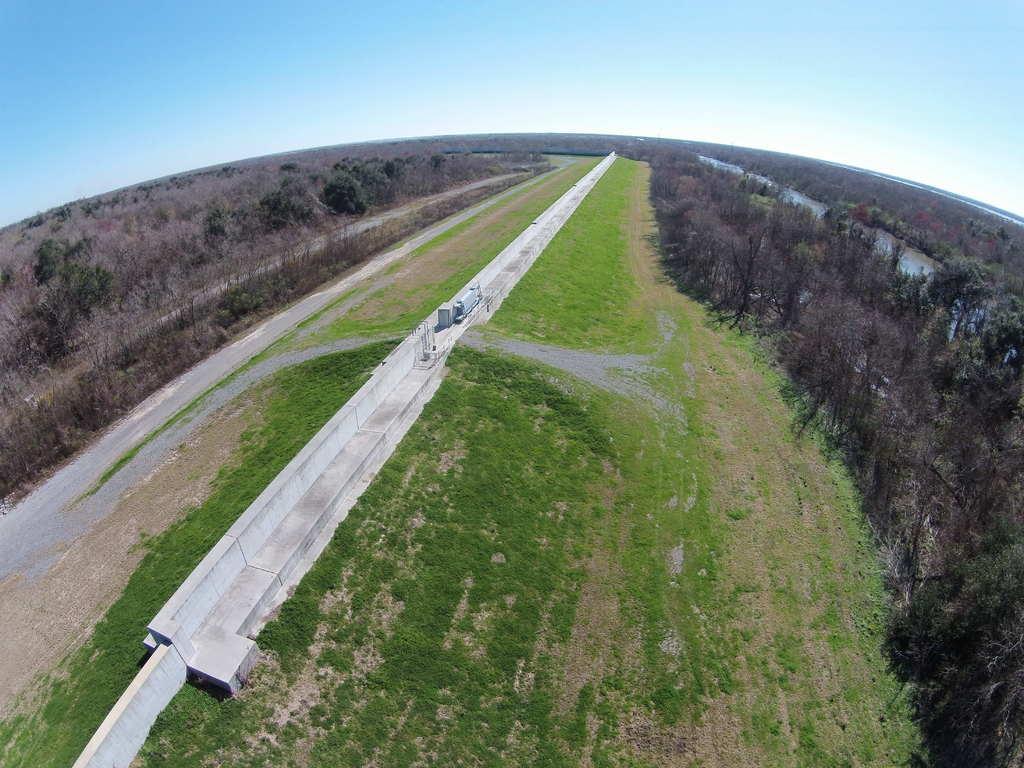Can you describe this image briefly? In this image we can see motor vehicles on the road, ground, trees and sky with clouds. 